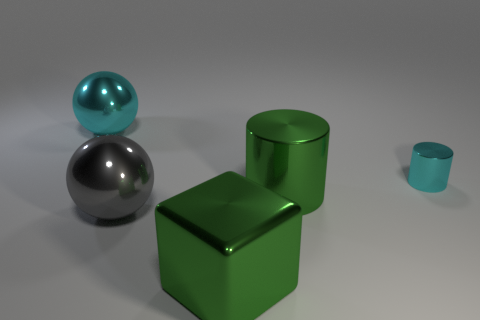How many things are either big shiny objects or large metallic things that are right of the cube?
Keep it short and to the point. 4. Is the number of tiny cyan objects less than the number of big brown metallic cubes?
Your answer should be very brief. No. The big sphere behind the metal cylinder to the left of the small cyan cylinder is what color?
Provide a succinct answer. Cyan. What number of shiny things are either green cylinders or tiny brown spheres?
Your response must be concise. 1. Are there any large gray cylinders?
Make the answer very short. No. Does the green shiny thing that is behind the large gray metallic ball have the same shape as the cyan object that is on the left side of the gray metallic ball?
Your answer should be very brief. No. Is there another big ball that has the same material as the gray ball?
Ensure brevity in your answer.  Yes. Is the material of the object that is in front of the big gray metallic sphere the same as the big green cylinder?
Provide a short and direct response. Yes. Is the number of metal objects that are in front of the gray object greater than the number of large green objects that are right of the large shiny cylinder?
Offer a terse response. Yes. There is a cylinder that is the same size as the green metallic block; what is its color?
Provide a succinct answer. Green. 